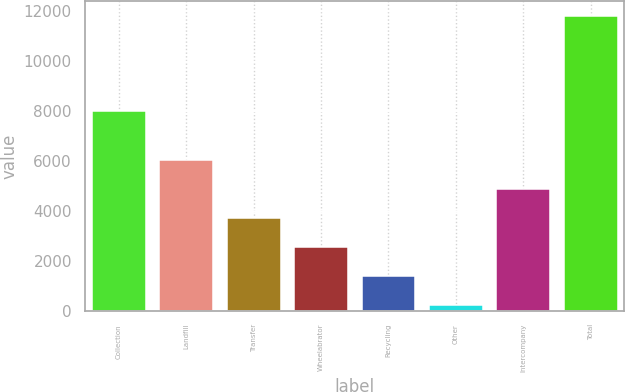Convert chart to OTSL. <chart><loc_0><loc_0><loc_500><loc_500><bar_chart><fcel>Collection<fcel>Landfill<fcel>Transfer<fcel>Wheelabrator<fcel>Recycling<fcel>Other<fcel>Intercompany<fcel>Total<nl><fcel>7980<fcel>6018<fcel>3708.8<fcel>2554.2<fcel>1399.6<fcel>245<fcel>4863.4<fcel>11791<nl></chart> 